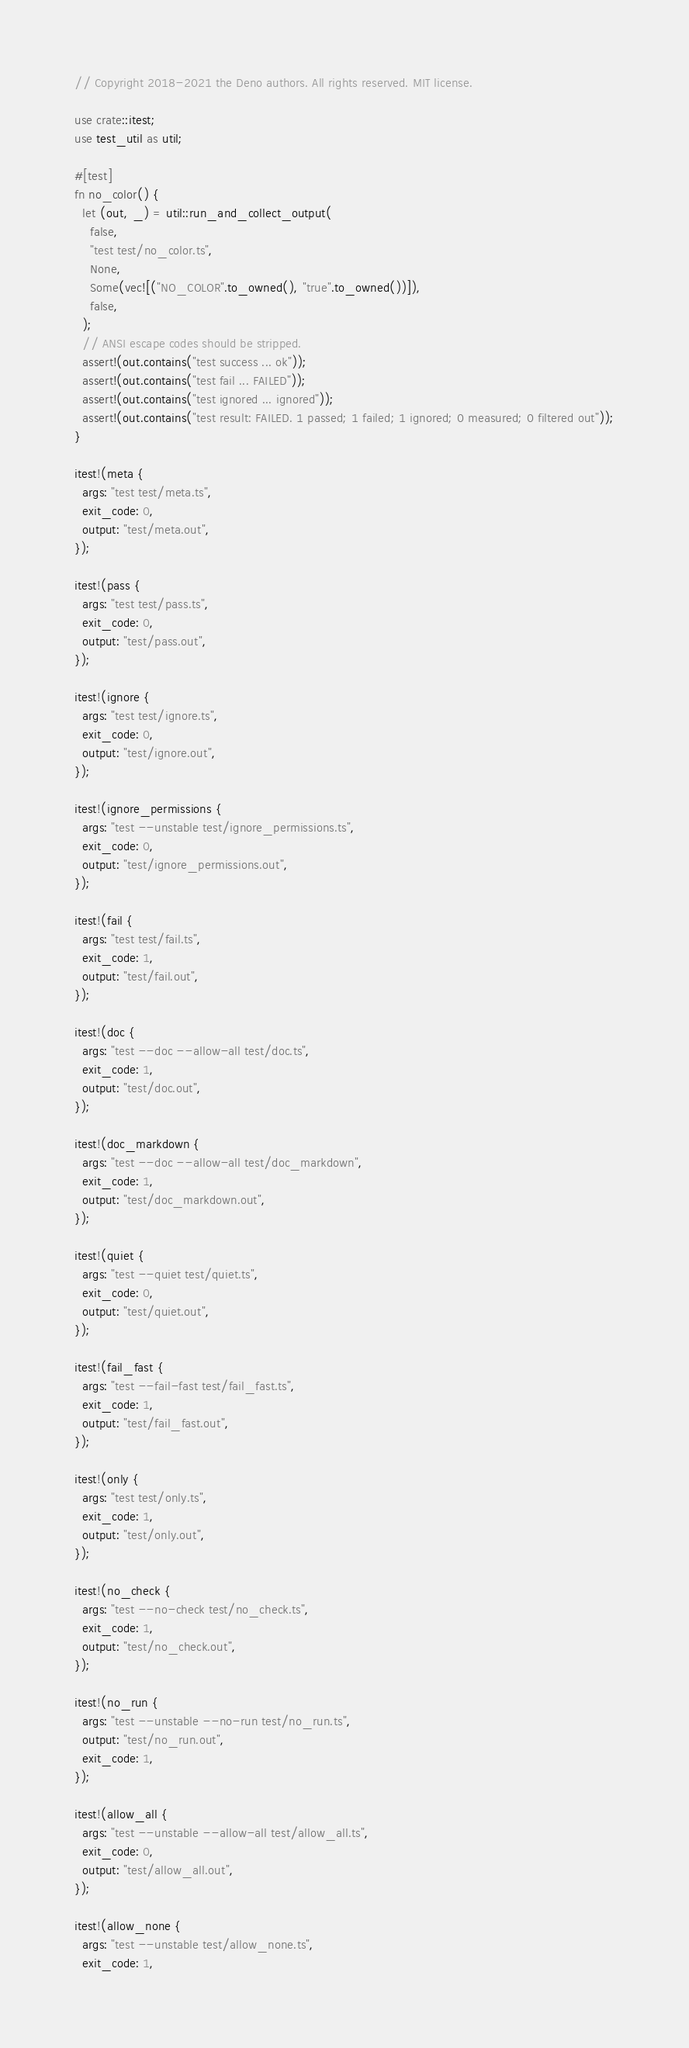Convert code to text. <code><loc_0><loc_0><loc_500><loc_500><_Rust_>// Copyright 2018-2021 the Deno authors. All rights reserved. MIT license.

use crate::itest;
use test_util as util;

#[test]
fn no_color() {
  let (out, _) = util::run_and_collect_output(
    false,
    "test test/no_color.ts",
    None,
    Some(vec![("NO_COLOR".to_owned(), "true".to_owned())]),
    false,
  );
  // ANSI escape codes should be stripped.
  assert!(out.contains("test success ... ok"));
  assert!(out.contains("test fail ... FAILED"));
  assert!(out.contains("test ignored ... ignored"));
  assert!(out.contains("test result: FAILED. 1 passed; 1 failed; 1 ignored; 0 measured; 0 filtered out"));
}

itest!(meta {
  args: "test test/meta.ts",
  exit_code: 0,
  output: "test/meta.out",
});

itest!(pass {
  args: "test test/pass.ts",
  exit_code: 0,
  output: "test/pass.out",
});

itest!(ignore {
  args: "test test/ignore.ts",
  exit_code: 0,
  output: "test/ignore.out",
});

itest!(ignore_permissions {
  args: "test --unstable test/ignore_permissions.ts",
  exit_code: 0,
  output: "test/ignore_permissions.out",
});

itest!(fail {
  args: "test test/fail.ts",
  exit_code: 1,
  output: "test/fail.out",
});

itest!(doc {
  args: "test --doc --allow-all test/doc.ts",
  exit_code: 1,
  output: "test/doc.out",
});

itest!(doc_markdown {
  args: "test --doc --allow-all test/doc_markdown",
  exit_code: 1,
  output: "test/doc_markdown.out",
});

itest!(quiet {
  args: "test --quiet test/quiet.ts",
  exit_code: 0,
  output: "test/quiet.out",
});

itest!(fail_fast {
  args: "test --fail-fast test/fail_fast.ts",
  exit_code: 1,
  output: "test/fail_fast.out",
});

itest!(only {
  args: "test test/only.ts",
  exit_code: 1,
  output: "test/only.out",
});

itest!(no_check {
  args: "test --no-check test/no_check.ts",
  exit_code: 1,
  output: "test/no_check.out",
});

itest!(no_run {
  args: "test --unstable --no-run test/no_run.ts",
  output: "test/no_run.out",
  exit_code: 1,
});

itest!(allow_all {
  args: "test --unstable --allow-all test/allow_all.ts",
  exit_code: 0,
  output: "test/allow_all.out",
});

itest!(allow_none {
  args: "test --unstable test/allow_none.ts",
  exit_code: 1,</code> 